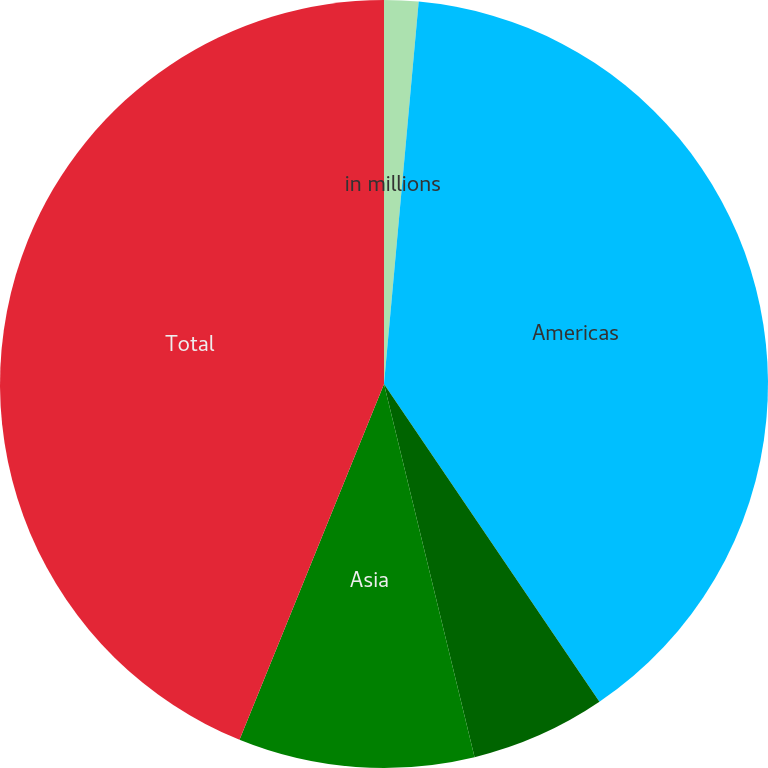<chart> <loc_0><loc_0><loc_500><loc_500><pie_chart><fcel>in millions<fcel>Americas<fcel>Europe Middle East and Africa<fcel>Asia<fcel>Total<nl><fcel>1.44%<fcel>39.08%<fcel>5.69%<fcel>9.93%<fcel>43.86%<nl></chart> 